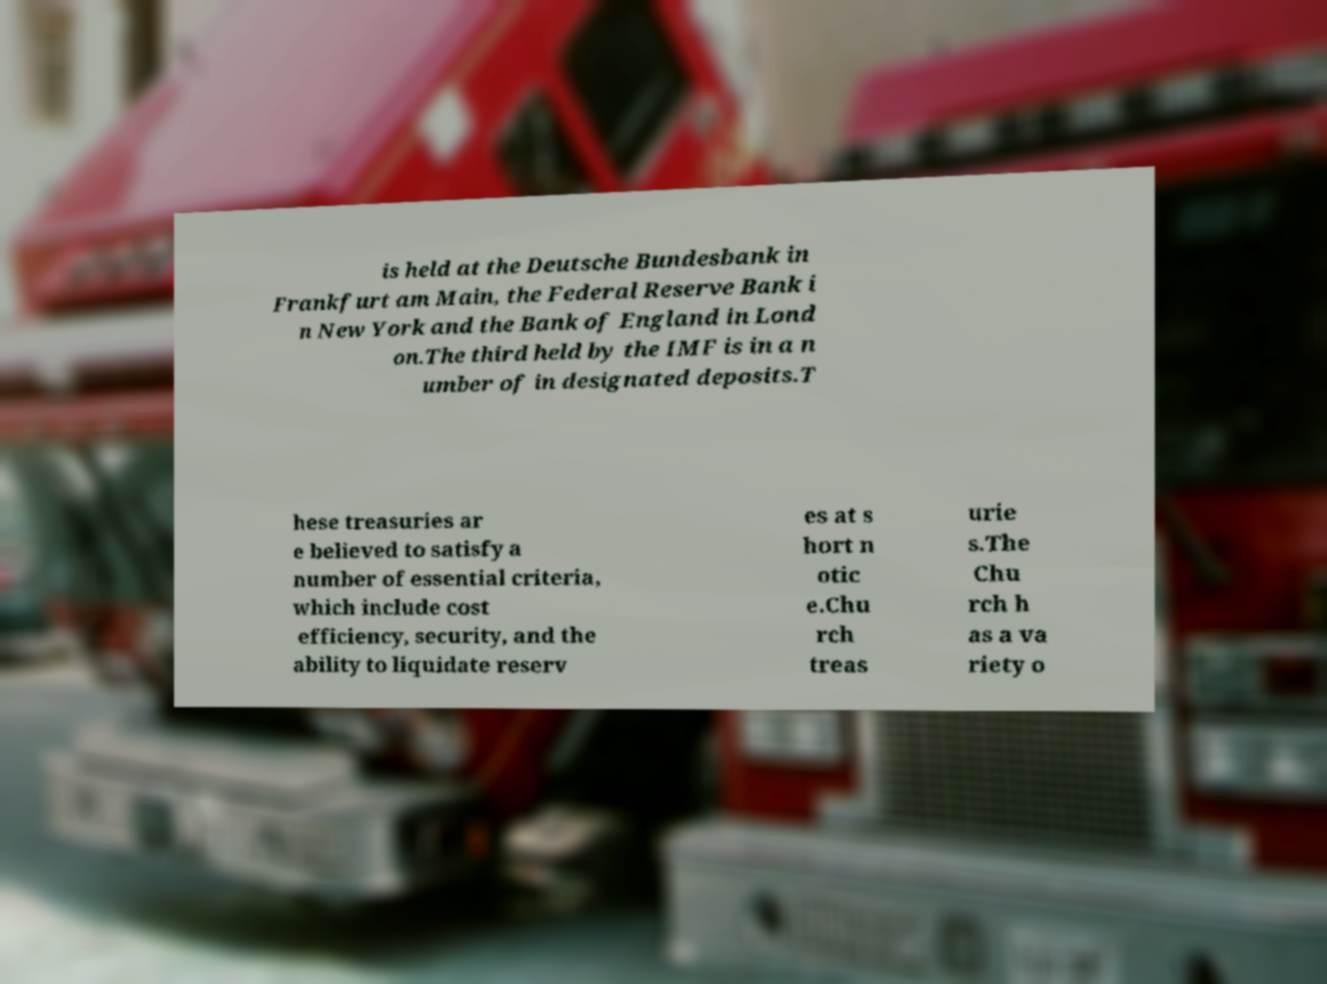For documentation purposes, I need the text within this image transcribed. Could you provide that? is held at the Deutsche Bundesbank in Frankfurt am Main, the Federal Reserve Bank i n New York and the Bank of England in Lond on.The third held by the IMF is in a n umber of in designated deposits.T hese treasuries ar e believed to satisfy a number of essential criteria, which include cost efficiency, security, and the ability to liquidate reserv es at s hort n otic e.Chu rch treas urie s.The Chu rch h as a va riety o 